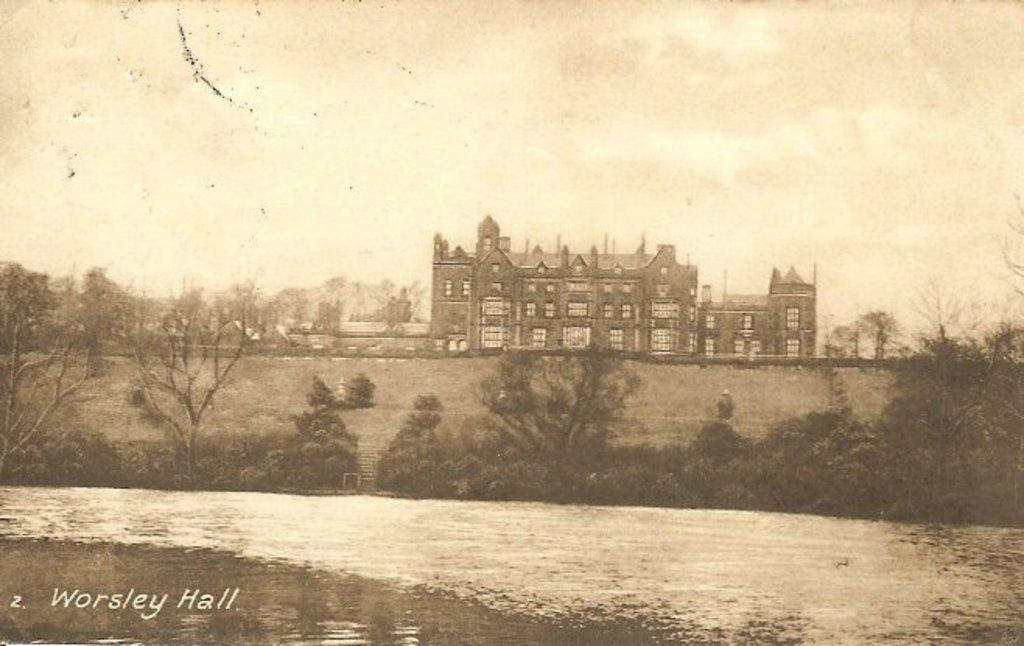What is the color scheme of the image? The image is black and white. What type of structure can be seen in the image? There is a building with windows in the image. What is located in front of the building in the image? Trees are present in front of the building in the image. Is there any text or marking at the bottom of the image? Yes, there is a watermark at the bottom of the image. What is the title of the book that is being read by the person in the image? There is no person or book present in the image; it features a building with windows and trees in front. 